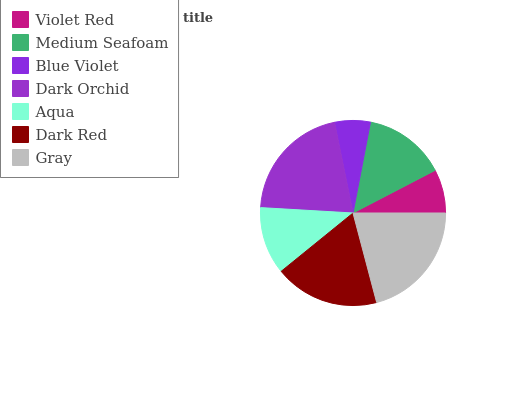Is Blue Violet the minimum?
Answer yes or no. Yes. Is Gray the maximum?
Answer yes or no. Yes. Is Medium Seafoam the minimum?
Answer yes or no. No. Is Medium Seafoam the maximum?
Answer yes or no. No. Is Medium Seafoam greater than Violet Red?
Answer yes or no. Yes. Is Violet Red less than Medium Seafoam?
Answer yes or no. Yes. Is Violet Red greater than Medium Seafoam?
Answer yes or no. No. Is Medium Seafoam less than Violet Red?
Answer yes or no. No. Is Medium Seafoam the high median?
Answer yes or no. Yes. Is Medium Seafoam the low median?
Answer yes or no. Yes. Is Blue Violet the high median?
Answer yes or no. No. Is Blue Violet the low median?
Answer yes or no. No. 